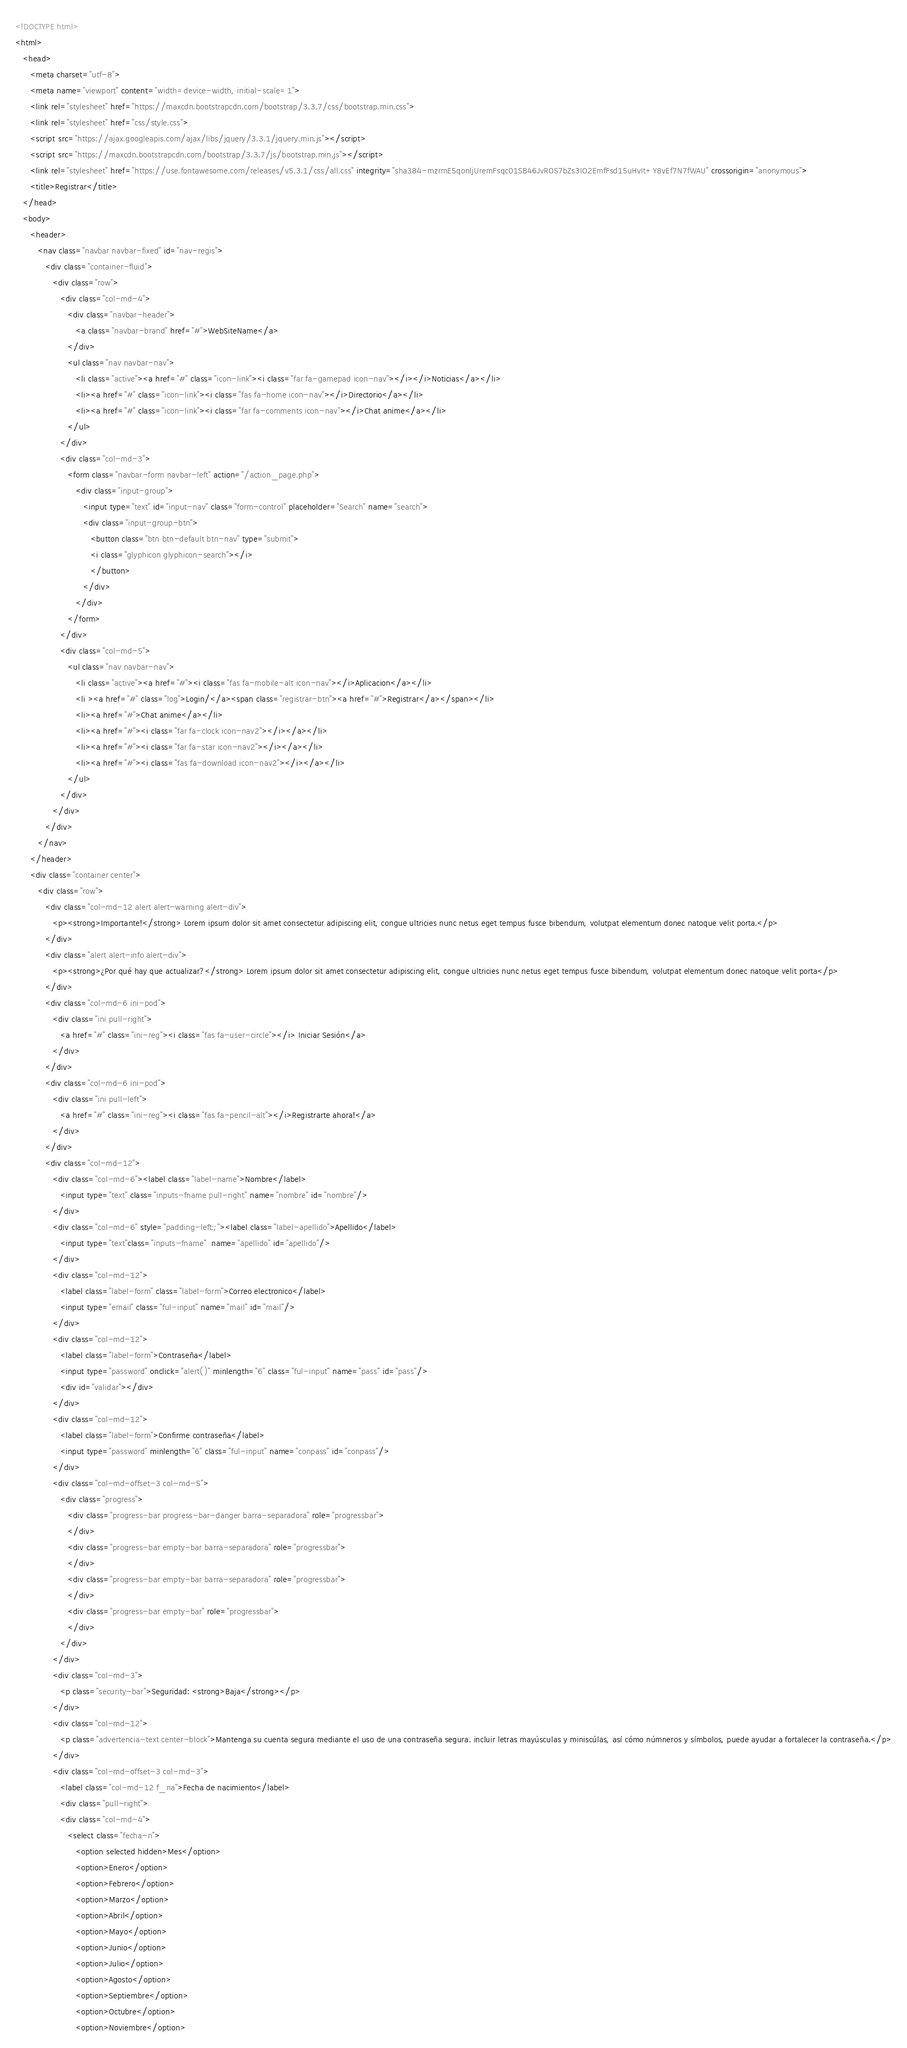Convert code to text. <code><loc_0><loc_0><loc_500><loc_500><_HTML_><!DOCTYPE html>
<html>
   <head>
      <meta charset="utf-8">
      <meta name="viewport" content="width=device-width, initial-scale=1">
      <link rel="stylesheet" href="https://maxcdn.bootstrapcdn.com/bootstrap/3.3.7/css/bootstrap.min.css">
      <link rel="stylesheet" href="css/style.css">
      <script src="https://ajax.googleapis.com/ajax/libs/jquery/3.3.1/jquery.min.js"></script>
      <script src="https://maxcdn.bootstrapcdn.com/bootstrap/3.3.7/js/bootstrap.min.js"></script>
      <link rel="stylesheet" href="https://use.fontawesome.com/releases/v5.3.1/css/all.css" integrity="sha384-mzrmE5qonljUremFsqc01SB46JvROS7bZs3IO2EmfFsd15uHvIt+Y8vEf7N7fWAU" crossorigin="anonymous">
      <title>Registrar</title>
   </head>
   <body>
      <header>
         <nav class="navbar navbar-fixed" id="nav-regis">
            <div class="container-fluid">
               <div class="row">
                  <div class="col-md-4">
                     <div class="navbar-header">
                        <a class="navbar-brand" href="#">WebSiteName</a>
                     </div>
                     <ul class="nav navbar-nav">
                        <li class="active"><a href="#" class="icon-link"><i class="far fa-gamepad icon-nav"></i></i>Noticias</a></li>
                        <li><a href="#" class="icon-link"><i class="fas fa-home icon-nav"></i>Directorio</a></li>
                        <li><a href="#" class="icon-link"><i class="far fa-comments icon-nav"></i>Chat anime</a></li>
                     </ul>
                  </div>
                  <div class="col-md-3">
                     <form class="navbar-form navbar-left" action="/action_page.php">
                        <div class="input-group">
                           <input type="text" id="input-nav" class="form-control" placeholder="Search" name="search">
                           <div class="input-group-btn">
                              <button class="btn btn-default btn-nav" type="submit">
                              <i class="glyphicon glyphicon-search"></i>
                              </button>
                           </div>
                        </div>
                     </form>
                  </div>
                  <div class="col-md-5">
                     <ul class="nav navbar-nav">
                        <li class="active"><a href="#"><i class="fas fa-mobile-alt icon-nav"></i>Aplicacion</a></li>
                        <li ><a href="#" class="log">Login/</a><span class="registrar-btn"><a href="#">Registrar</a></span></li>
                        <li><a href="#">Chat anime</a></li>
                        <li><a href="#"><i class="far fa-clock icon-nav2"></i></a></li>
                        <li><a href="#"><i class="far fa-star icon-nav2"></i></a></li>
                        <li><a href="#"><i class="fas fa-download icon-nav2"></i></a></li>
                     </ul>
                  </div>
               </div>
            </div>
         </nav>
      </header>
      <div class="container center">
         <div class="row">
            <div class="col-md-12 alert alert-warning alert-div">
               <p><strong>Importante!</strong> Lorem ipsum dolor sit amet consectetur adipiscing elit, congue ultricies nunc netus eget tempus fusce bibendum, volutpat elementum donec natoque velit porta.</p>
            </div>
            <div class="alert alert-info alert-div">
               <p><strong>¿Por qué hay que actualizar?</strong> Lorem ipsum dolor sit amet consectetur adipiscing elit, congue ultricies nunc netus eget tempus fusce bibendum, volutpat elementum donec natoque velit porta</p>
            </div>
            <div class="col-md-6 ini-pod">
               <div class="ini pull-right">
                  <a href="#" class="ini-reg"><i class="fas fa-user-circle"></i> Iniciar Sesión</a>
               </div>
            </div>
            <div class="col-md-6 ini-pod">
               <div class="ini pull-left">
                  <a href="#" class="ini-reg"><i class="fas fa-pencil-alt"></i>Registrarte ahora!</a>
               </div>
            </div>
            <div class="col-md-12">
               <div class="col-md-6"><label class="label-name">Nombre</label>
                  <input type="text" class="inputs-fname pull-right" name="nombre" id="nombre"/>
               </div>
               <div class="col-md-6" style="padding-left:;"><label class="label-apellido">Apellido</label>
                  <input type="text"class="inputs-fname"  name="apellido" id="apellido"/>
               </div>
               <div class="col-md-12">
                  <label class="label-form" class="label-form">Correo electronico</label>
                  <input type="email" class="ful-input" name="mail" id="mail"/>
               </div>
               <div class="col-md-12">
                  <label class="label-form">Contraseña</label>
                  <input type="password" onclick="alert()" minlength="6" class="ful-input" name="pass" id="pass"/>
                  <div id="validar"></div>
               </div>
               <div class="col-md-12">
                  <label class="label-form">Confirme contraseña</label>
                  <input type="password" minlength="6" class="ful-input" name="conpass" id="conpass"/>
               </div>
               <div class="col-md-offset-3 col-md-5">
                  <div class="progress">
                     <div class="progress-bar progress-bar-danger barra-separadora" role="progressbar">   
                     </div>
                     <div class="progress-bar empty-bar barra-separadora" role="progressbar">
                     </div>
                     <div class="progress-bar empty-bar barra-separadora" role="progressbar">
                     </div>
                     <div class="progress-bar empty-bar" role="progressbar">
                     </div>
                  </div>
               </div>
               <div class="col-md-3">
                  <p class="security-bar">Seguridad: <strong>Baja</strong></p>
               </div>
               <div class="col-md-12">
                  <p class="advertencia-text center-block">Mantenga su cuenta segura mediante el uso de una contraseña segura. incluir letras mayúsculas y miniscúlas, así cómo númneros y símbolos, puede ayudar a fortalecer la contraseña.</p>
               </div>
               <div class="col-md-offset-3 col-md-3">
                  <label class="col-md-12 f_na">Fecha de nacimiento</label>
                  <div class="pull-right">
                  <div class="col-md-4">
                     <select class="fecha-n">
                        <option selected hidden>Mes</option>
                        <option>Enero</option>
                        <option>Febrero</option>
                        <option>Marzo</option>
                        <option>Abril</option>
                        <option>Mayo</option>
                        <option>Junio</option>
                        <option>Julio</option>
                        <option>Agosto</option>
                        <option>Septiembre</option>
                        <option>Octubre</option>
                        <option>Noviembre</option></code> 